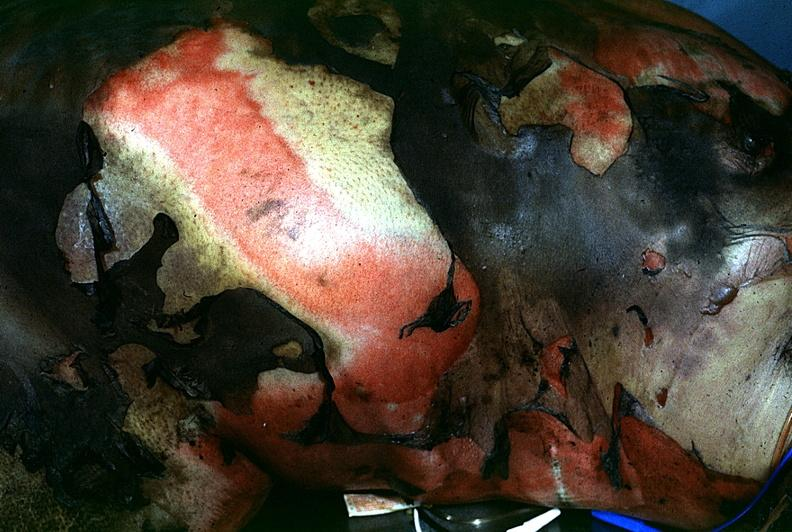where is this?
Answer the question using a single word or phrase. Skin 